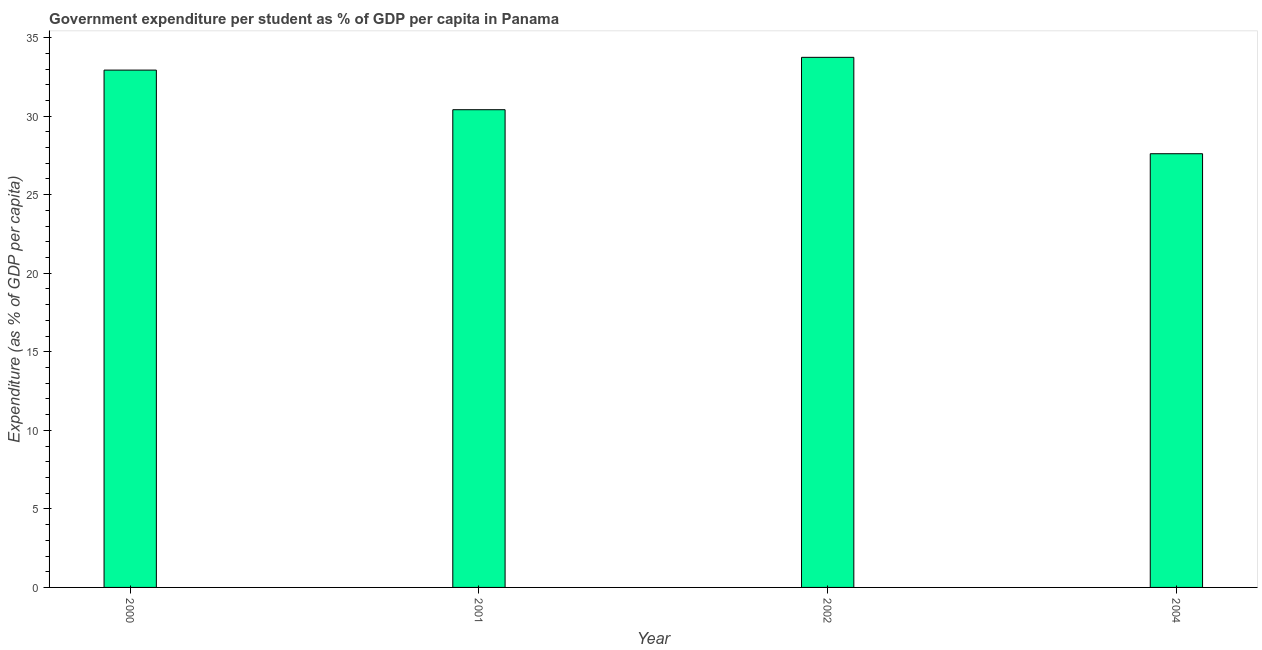Does the graph contain any zero values?
Your answer should be compact. No. What is the title of the graph?
Ensure brevity in your answer.  Government expenditure per student as % of GDP per capita in Panama. What is the label or title of the Y-axis?
Offer a terse response. Expenditure (as % of GDP per capita). What is the government expenditure per student in 2001?
Your answer should be compact. 30.41. Across all years, what is the maximum government expenditure per student?
Your response must be concise. 33.74. Across all years, what is the minimum government expenditure per student?
Make the answer very short. 27.61. In which year was the government expenditure per student maximum?
Offer a very short reply. 2002. What is the sum of the government expenditure per student?
Ensure brevity in your answer.  124.69. What is the difference between the government expenditure per student in 2000 and 2001?
Provide a succinct answer. 2.52. What is the average government expenditure per student per year?
Give a very brief answer. 31.17. What is the median government expenditure per student?
Offer a terse response. 31.67. Do a majority of the years between 2001 and 2004 (inclusive) have government expenditure per student greater than 16 %?
Your response must be concise. Yes. What is the ratio of the government expenditure per student in 2000 to that in 2002?
Make the answer very short. 0.98. Is the government expenditure per student in 2001 less than that in 2002?
Make the answer very short. Yes. Is the difference between the government expenditure per student in 2002 and 2004 greater than the difference between any two years?
Provide a succinct answer. Yes. What is the difference between the highest and the second highest government expenditure per student?
Provide a succinct answer. 0.81. What is the difference between the highest and the lowest government expenditure per student?
Offer a very short reply. 6.14. What is the difference between two consecutive major ticks on the Y-axis?
Keep it short and to the point. 5. Are the values on the major ticks of Y-axis written in scientific E-notation?
Your answer should be very brief. No. What is the Expenditure (as % of GDP per capita) of 2000?
Ensure brevity in your answer.  32.93. What is the Expenditure (as % of GDP per capita) of 2001?
Your answer should be very brief. 30.41. What is the Expenditure (as % of GDP per capita) in 2002?
Provide a short and direct response. 33.74. What is the Expenditure (as % of GDP per capita) in 2004?
Ensure brevity in your answer.  27.61. What is the difference between the Expenditure (as % of GDP per capita) in 2000 and 2001?
Your answer should be very brief. 2.52. What is the difference between the Expenditure (as % of GDP per capita) in 2000 and 2002?
Provide a succinct answer. -0.81. What is the difference between the Expenditure (as % of GDP per capita) in 2000 and 2004?
Your answer should be compact. 5.32. What is the difference between the Expenditure (as % of GDP per capita) in 2001 and 2002?
Make the answer very short. -3.33. What is the difference between the Expenditure (as % of GDP per capita) in 2001 and 2004?
Keep it short and to the point. 2.8. What is the difference between the Expenditure (as % of GDP per capita) in 2002 and 2004?
Provide a short and direct response. 6.14. What is the ratio of the Expenditure (as % of GDP per capita) in 2000 to that in 2001?
Your answer should be compact. 1.08. What is the ratio of the Expenditure (as % of GDP per capita) in 2000 to that in 2002?
Provide a succinct answer. 0.98. What is the ratio of the Expenditure (as % of GDP per capita) in 2000 to that in 2004?
Give a very brief answer. 1.19. What is the ratio of the Expenditure (as % of GDP per capita) in 2001 to that in 2002?
Provide a short and direct response. 0.9. What is the ratio of the Expenditure (as % of GDP per capita) in 2001 to that in 2004?
Make the answer very short. 1.1. What is the ratio of the Expenditure (as % of GDP per capita) in 2002 to that in 2004?
Keep it short and to the point. 1.22. 